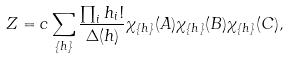Convert formula to latex. <formula><loc_0><loc_0><loc_500><loc_500>Z = c \sum _ { \{ h \} } \frac { \prod _ { i } h _ { i } ! } { \Delta ( h ) } \chi _ { \{ h \} } ( A ) \chi _ { \{ h \} } ( B ) \chi _ { \{ h \} } ( C ) ,</formula> 